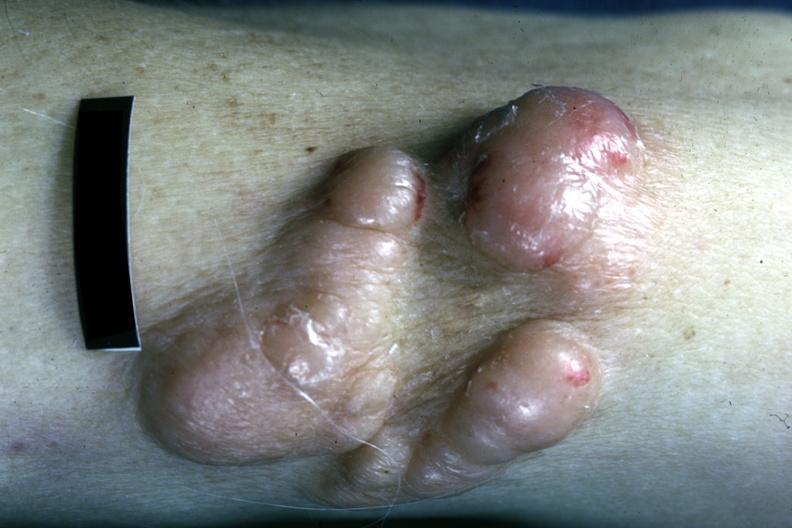what does this image show?
Answer the question using a single word or phrase. Close-up view of nodular skin lesions infiltrating plasma cells 